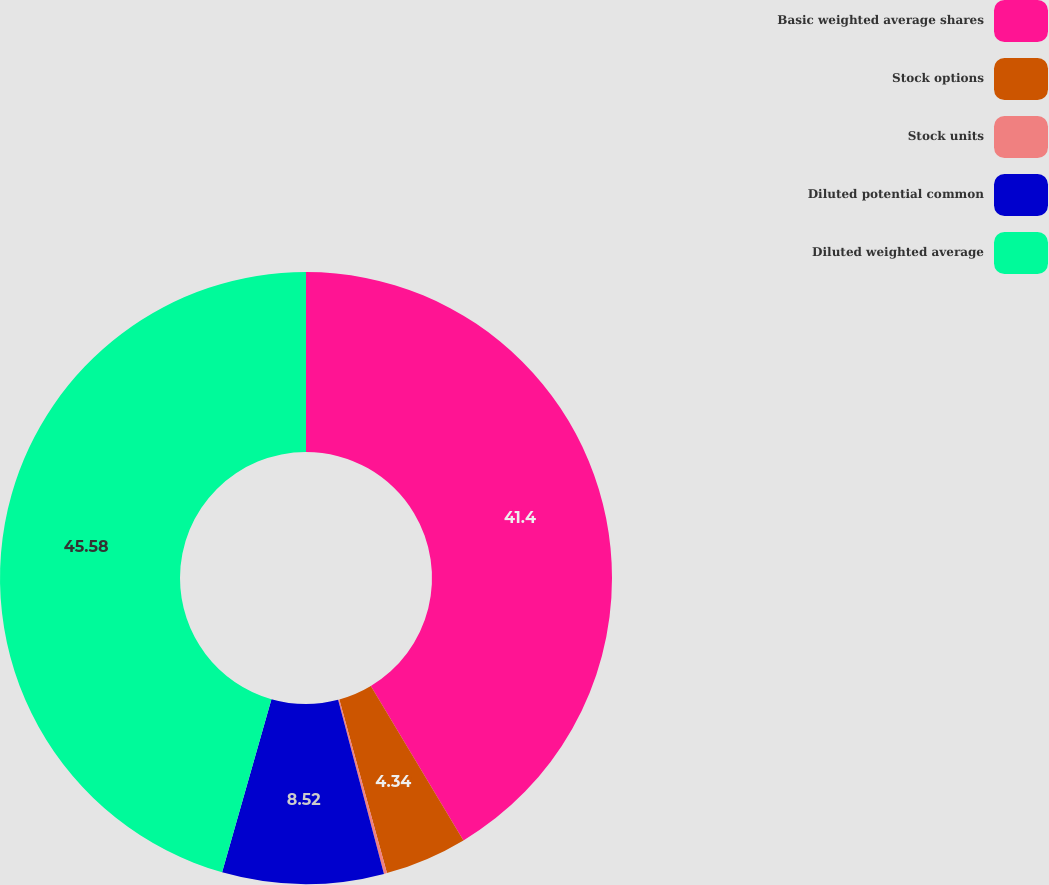Convert chart. <chart><loc_0><loc_0><loc_500><loc_500><pie_chart><fcel>Basic weighted average shares<fcel>Stock options<fcel>Stock units<fcel>Diluted potential common<fcel>Diluted weighted average<nl><fcel>41.39%<fcel>4.34%<fcel>0.16%<fcel>8.52%<fcel>45.57%<nl></chart> 